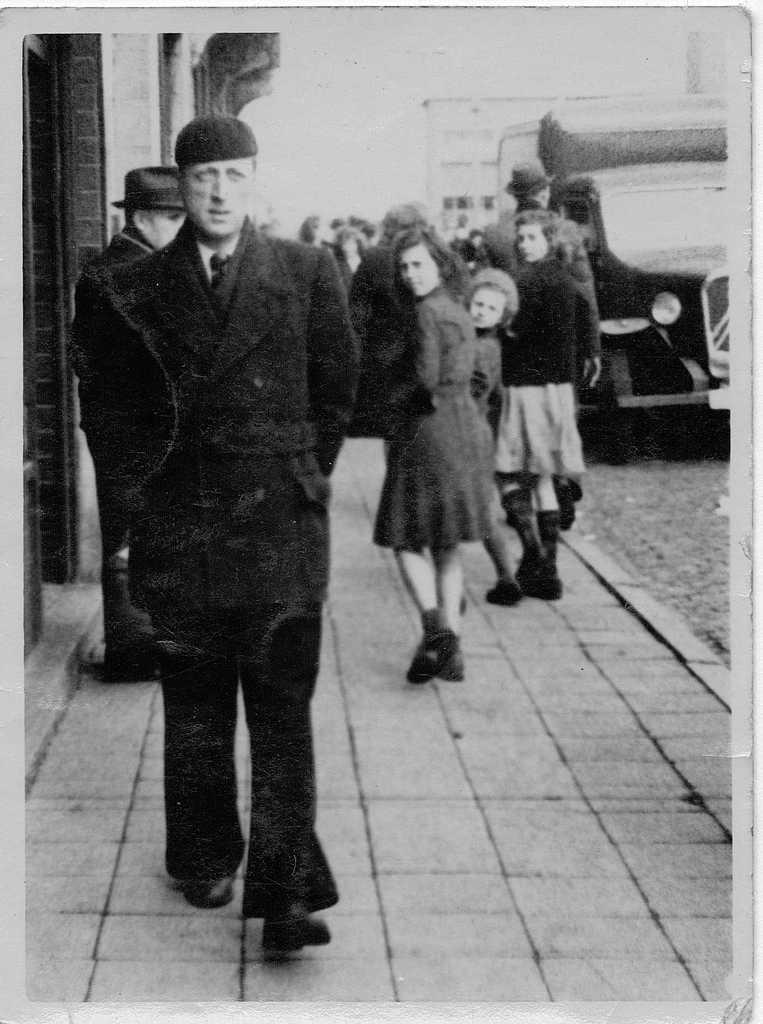What is the color scheme of the image? The image is black and white. Can you describe the subjects in the image? There are people in the image. What else can be seen in the image besides people? There is a vehicle in the image. Are there any accessories worn by the people in the image? Some people are wearing hats. What is visible in the background of the image? There is a building in the distance. How many children are present in the image? The provided facts do not mention children, so it is impossible to determine their presence or number in the image. 